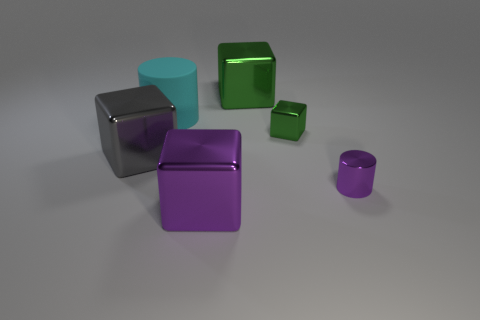What number of objects are objects to the right of the small metallic cube or small red cubes?
Your answer should be compact. 1. Does the big rubber thing have the same color as the metal cylinder?
Give a very brief answer. No. There is a shiny cube that is behind the cyan matte cylinder; how big is it?
Offer a terse response. Large. Are there any red rubber blocks that have the same size as the gray cube?
Provide a short and direct response. No. There is a cylinder in front of the gray metallic cube; is it the same size as the cyan cylinder?
Your answer should be compact. No. How big is the cyan rubber cylinder?
Keep it short and to the point. Large. What color is the cylinder that is in front of the green metallic thing in front of the cylinder behind the purple metallic cylinder?
Provide a succinct answer. Purple. There is a block that is in front of the large gray object; is it the same color as the matte cylinder?
Your answer should be very brief. No. What number of large blocks are right of the big rubber thing and in front of the large rubber thing?
Keep it short and to the point. 1. What size is the purple thing that is the same shape as the big gray metal object?
Make the answer very short. Large. 